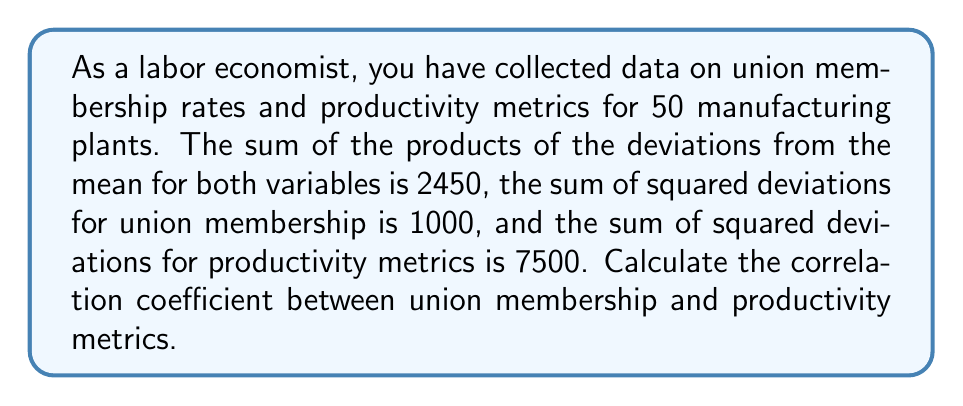Can you answer this question? To find the correlation coefficient, we'll use the formula:

$$ r = \frac{\sum_{i=1}^{n} (x_i - \bar{x})(y_i - \bar{y})}{\sqrt{\sum_{i=1}^{n} (x_i - \bar{x})^2 \sum_{i=1}^{n} (y_i - \bar{y})^2}} $$

Where:
- $r$ is the correlation coefficient
- $x_i$ represents union membership rates
- $y_i$ represents productivity metrics
- $\bar{x}$ and $\bar{y}$ are the means of $x$ and $y$ respectively

Given:
- $\sum_{i=1}^{n} (x_i - \bar{x})(y_i - \bar{y}) = 2450$
- $\sum_{i=1}^{n} (x_i - \bar{x})^2 = 1000$
- $\sum_{i=1}^{n} (y_i - \bar{y})^2 = 7500$

Now, let's substitute these values into the formula:

$$ r = \frac{2450}{\sqrt{1000 \times 7500}} $$

$$ r = \frac{2450}{\sqrt{7500000}} $$

$$ r = \frac{2450}{2738.61} $$

$$ r \approx 0.8946 $$
Answer: The correlation coefficient between union membership and productivity metrics is approximately 0.8946. 